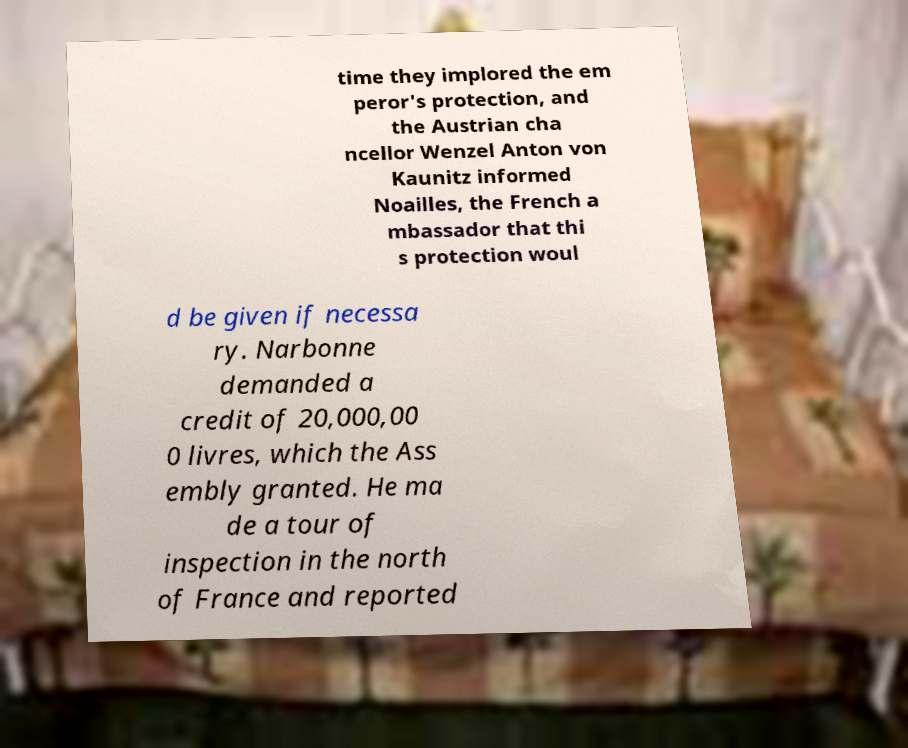For documentation purposes, I need the text within this image transcribed. Could you provide that? time they implored the em peror's protection, and the Austrian cha ncellor Wenzel Anton von Kaunitz informed Noailles, the French a mbassador that thi s protection woul d be given if necessa ry. Narbonne demanded a credit of 20,000,00 0 livres, which the Ass embly granted. He ma de a tour of inspection in the north of France and reported 